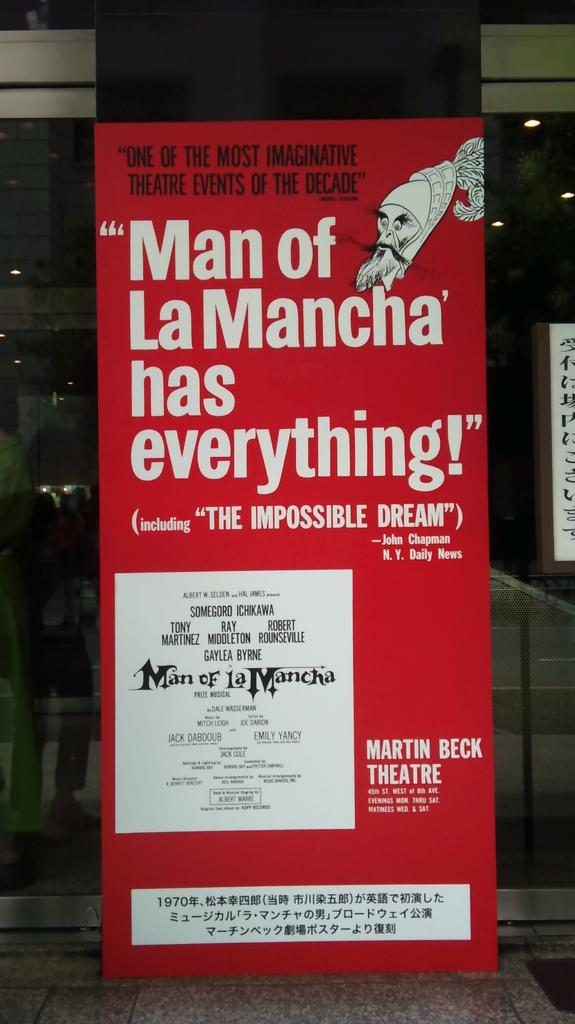<image>
Offer a succinct explanation of the picture presented. The poster advertises a theatre show and claims it is one of the most imaginative of the decade. 